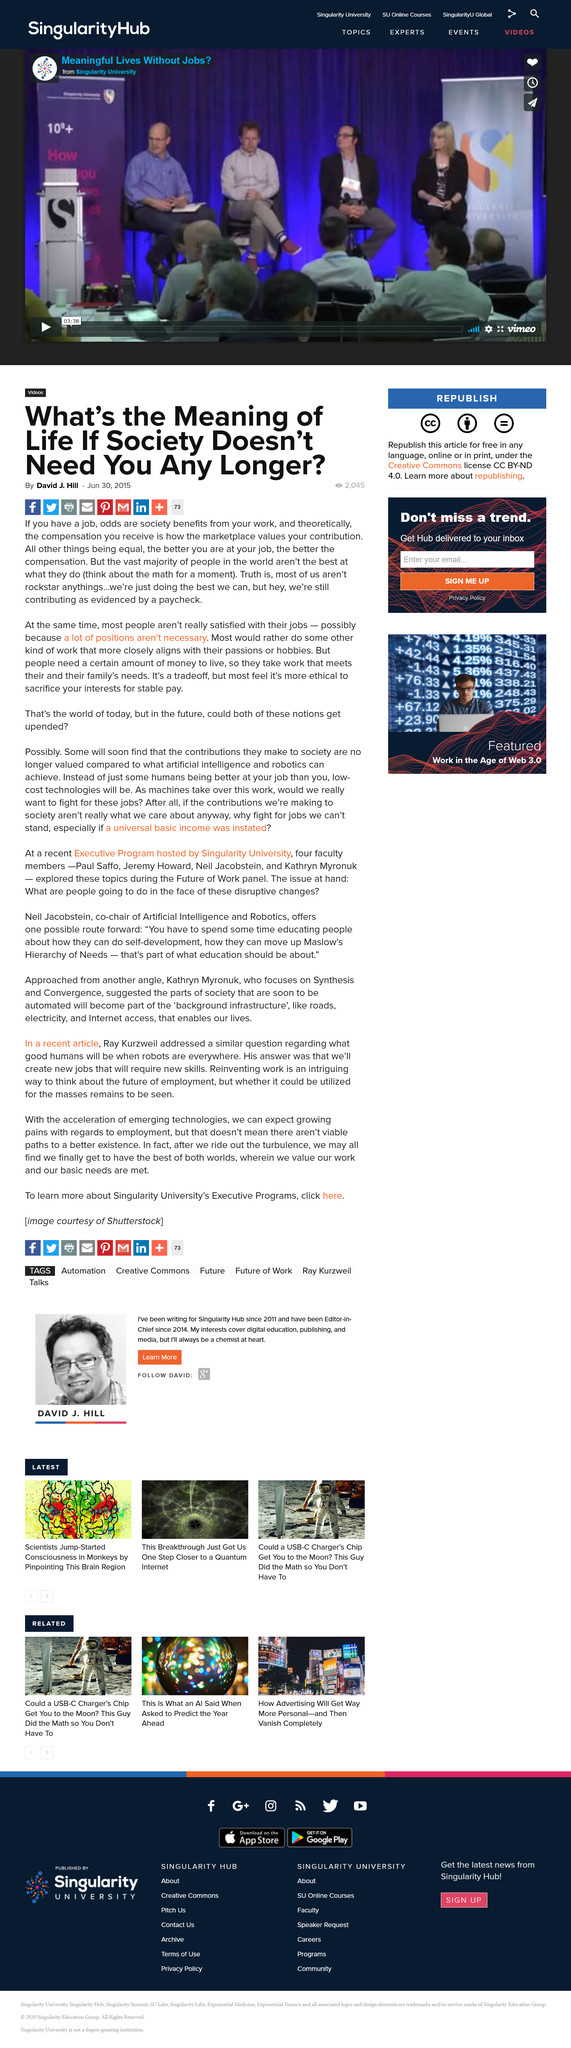Specify some key components in this picture. According to a recent survey, many people are not satisfied with their jobs because they feel that many positions are unnecessary and do not add value to the organization. The majority of people are not satisfied with their jobs. The compensation I receive is directly tied to the market's assessment of the value of my contributions, and it is theoretically determined by the amount of compensation that would be received in a market that is functioning properly. 